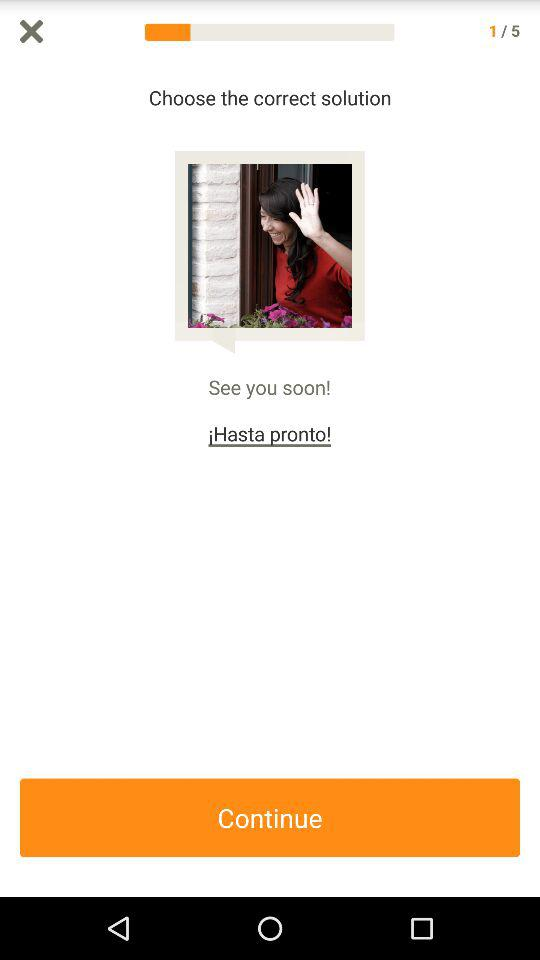What is the total number of questions? The total number of questions is 5. 